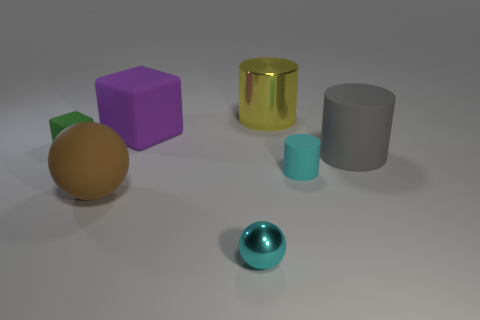There is a metal thing that is the same size as the green matte block; what shape is it?
Offer a terse response. Sphere. Is the number of big cubes greater than the number of metal objects?
Offer a very short reply. No. The thing that is both to the left of the purple rubber block and behind the cyan cylinder is made of what material?
Your answer should be compact. Rubber. How many other objects are the same material as the small ball?
Offer a very short reply. 1. What number of small objects are the same color as the big rubber cylinder?
Make the answer very short. 0. What size is the rubber thing that is right of the matte cylinder that is in front of the big cylinder in front of the small green matte thing?
Offer a very short reply. Large. What number of matte objects are purple things or cylinders?
Provide a short and direct response. 3. Do the big gray thing and the small cyan thing that is on the left side of the large metal cylinder have the same shape?
Give a very brief answer. No. Is the number of small cyan objects that are on the right side of the big gray rubber thing greater than the number of small cylinders that are in front of the tiny cyan shiny ball?
Your answer should be very brief. No. Is there any other thing of the same color as the tiny cube?
Keep it short and to the point. No. 